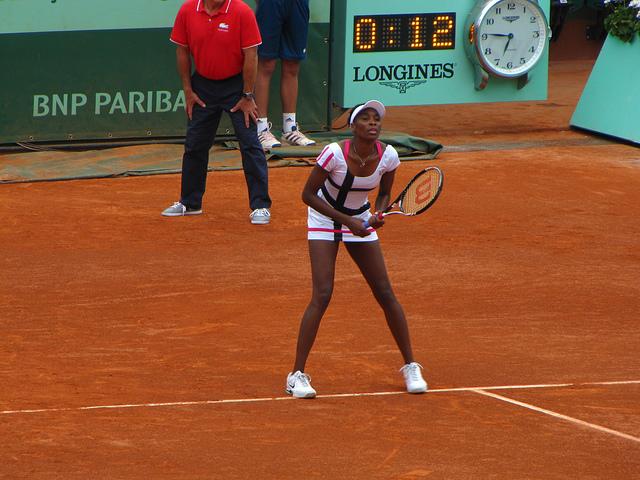What is the score?
Give a very brief answer. 0 : 12. What sport is it?
Keep it brief. Tennis. Are they playing on a clay court?
Answer briefly. Yes. What are the numbers on the digital clock?
Answer briefly. 0:12. 